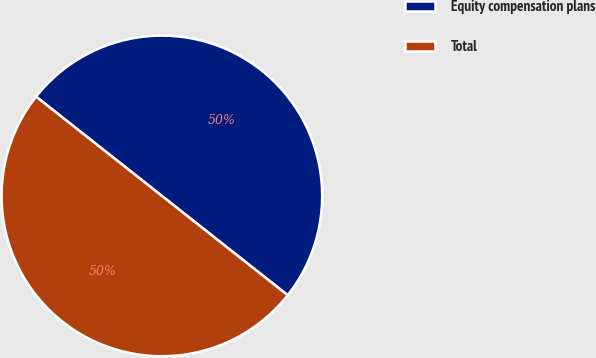<chart> <loc_0><loc_0><loc_500><loc_500><pie_chart><fcel>Equity compensation plans<fcel>Total<nl><fcel>50.0%<fcel>50.0%<nl></chart> 